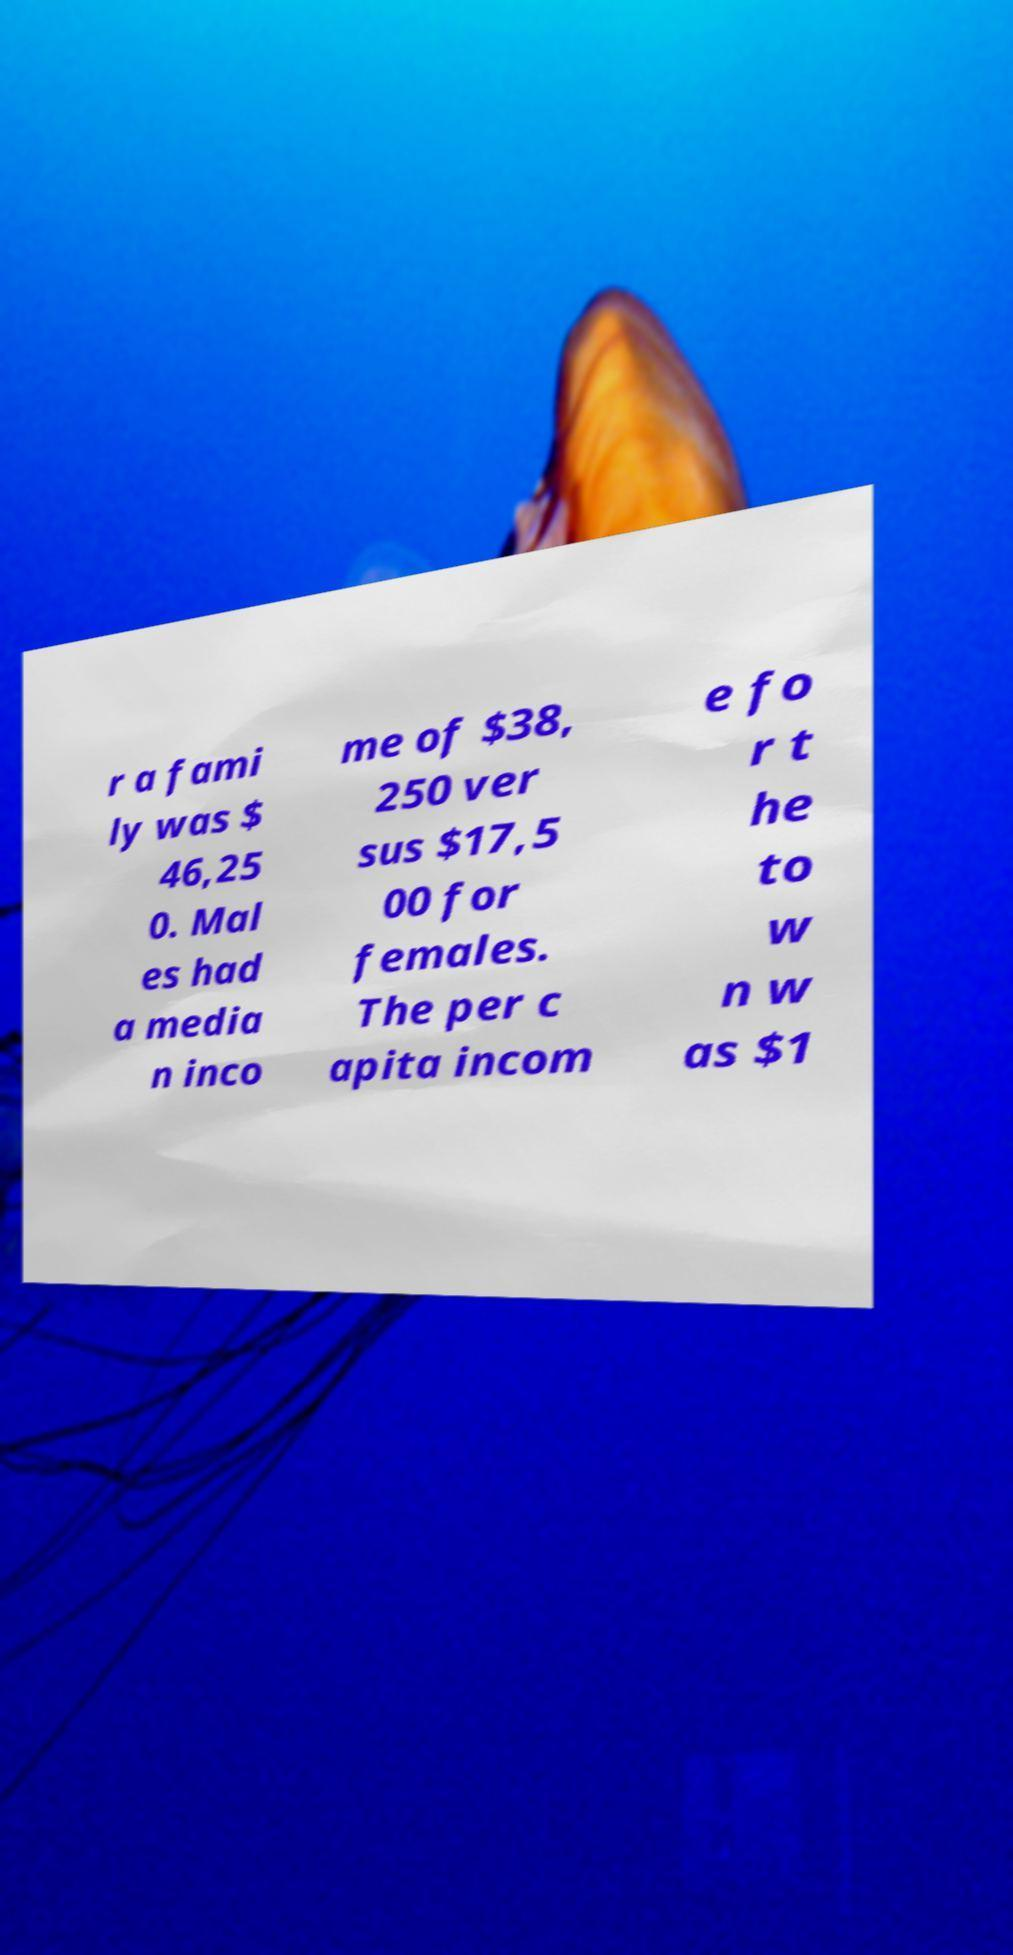What messages or text are displayed in this image? I need them in a readable, typed format. r a fami ly was $ 46,25 0. Mal es had a media n inco me of $38, 250 ver sus $17,5 00 for females. The per c apita incom e fo r t he to w n w as $1 